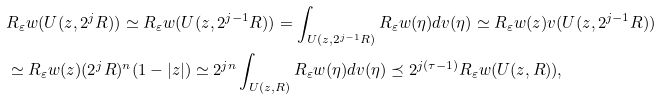Convert formula to latex. <formula><loc_0><loc_0><loc_500><loc_500>& R _ { \varepsilon } w ( U ( z , 2 ^ { j } R ) ) \simeq R _ { \varepsilon } w ( U ( z , 2 ^ { j - 1 } R ) ) = \int _ { U ( z , 2 ^ { j - 1 } R ) } R _ { \varepsilon } w ( \eta ) d v ( \eta ) \simeq R _ { \varepsilon } w ( z ) v ( U ( z , 2 ^ { j - 1 } R ) ) \\ & \simeq R _ { \varepsilon } w ( z ) ( 2 ^ { j } R ) ^ { n } ( 1 - | z | ) \simeq 2 ^ { j n } \int _ { U ( z , R ) } R _ { \varepsilon } w ( \eta ) d v ( \eta ) \preceq 2 ^ { j ( \tau - 1 ) } R _ { \varepsilon } w ( U ( z , R ) ) ,</formula> 